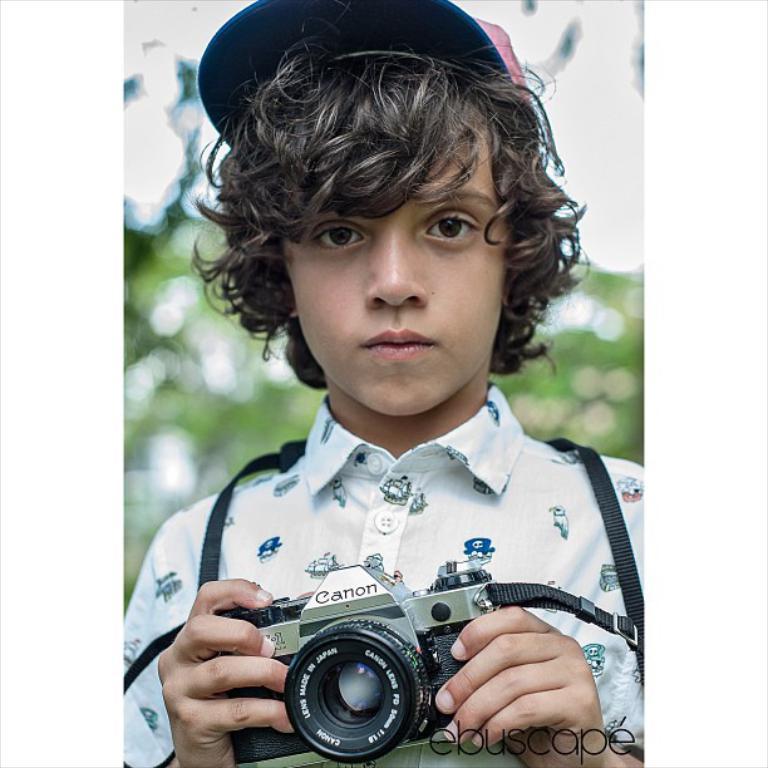Describe this image in one or two sentences. This boy is highlighted in this picture. This boy wore shirt, cap and holding a camera. 